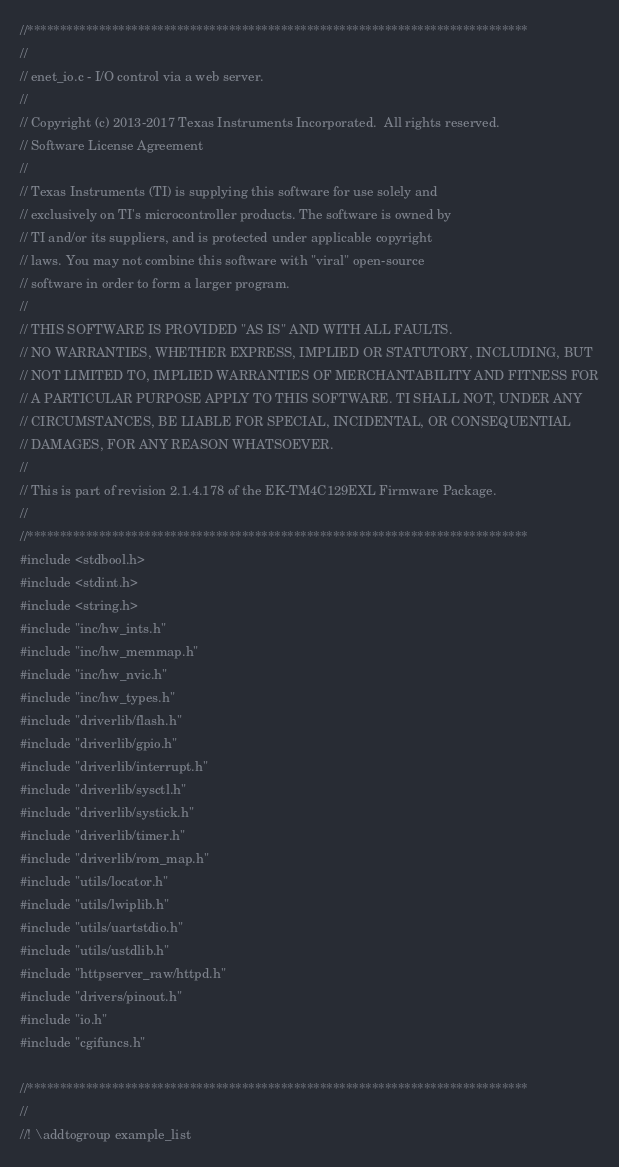<code> <loc_0><loc_0><loc_500><loc_500><_C_>//*****************************************************************************
//
// enet_io.c - I/O control via a web server.
//
// Copyright (c) 2013-2017 Texas Instruments Incorporated.  All rights reserved.
// Software License Agreement
// 
// Texas Instruments (TI) is supplying this software for use solely and
// exclusively on TI's microcontroller products. The software is owned by
// TI and/or its suppliers, and is protected under applicable copyright
// laws. You may not combine this software with "viral" open-source
// software in order to form a larger program.
// 
// THIS SOFTWARE IS PROVIDED "AS IS" AND WITH ALL FAULTS.
// NO WARRANTIES, WHETHER EXPRESS, IMPLIED OR STATUTORY, INCLUDING, BUT
// NOT LIMITED TO, IMPLIED WARRANTIES OF MERCHANTABILITY AND FITNESS FOR
// A PARTICULAR PURPOSE APPLY TO THIS SOFTWARE. TI SHALL NOT, UNDER ANY
// CIRCUMSTANCES, BE LIABLE FOR SPECIAL, INCIDENTAL, OR CONSEQUENTIAL
// DAMAGES, FOR ANY REASON WHATSOEVER.
// 
// This is part of revision 2.1.4.178 of the EK-TM4C129EXL Firmware Package.
//
//*****************************************************************************
#include <stdbool.h>
#include <stdint.h>
#include <string.h>
#include "inc/hw_ints.h"
#include "inc/hw_memmap.h"
#include "inc/hw_nvic.h"
#include "inc/hw_types.h"
#include "driverlib/flash.h"
#include "driverlib/gpio.h"
#include "driverlib/interrupt.h"
#include "driverlib/sysctl.h"
#include "driverlib/systick.h"
#include "driverlib/timer.h"
#include "driverlib/rom_map.h"
#include "utils/locator.h"
#include "utils/lwiplib.h"
#include "utils/uartstdio.h"
#include "utils/ustdlib.h"
#include "httpserver_raw/httpd.h"
#include "drivers/pinout.h"
#include "io.h"
#include "cgifuncs.h"

//*****************************************************************************
//
//! \addtogroup example_list</code> 